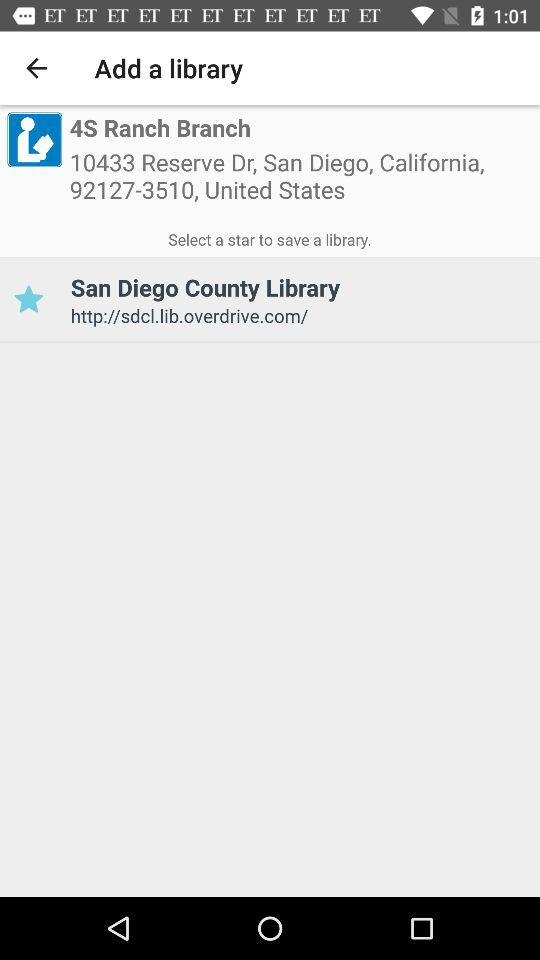What is the library name? The library name is San Diego County Library. 